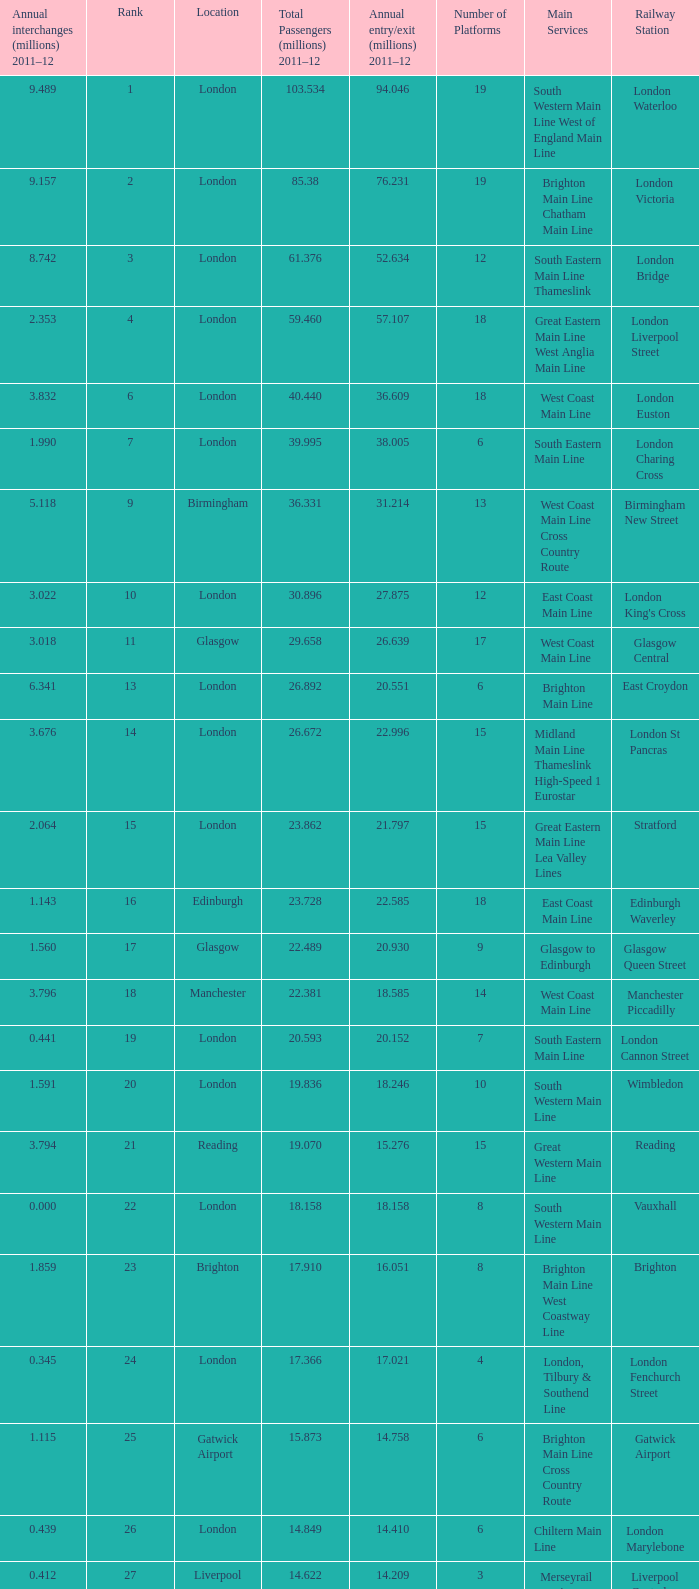What is the main service for the station with 14.849 million passengers 2011-12?  Chiltern Main Line. 